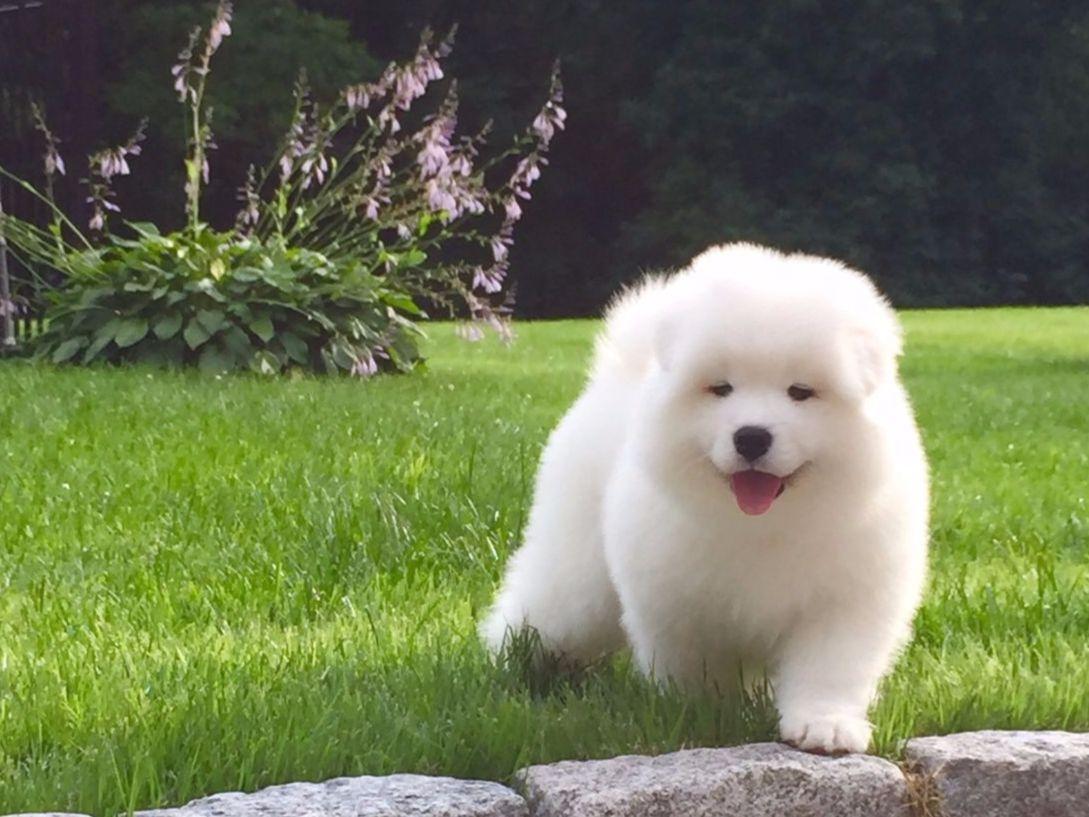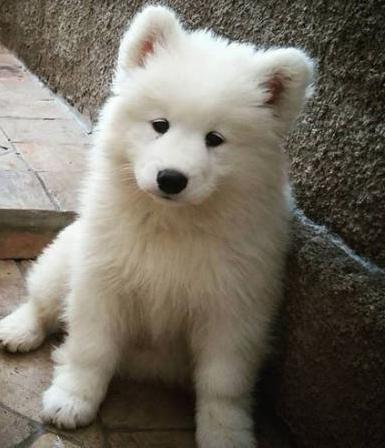The first image is the image on the left, the second image is the image on the right. For the images displayed, is the sentence "One image shows a small white pup next to a big white dog on green grass, and the other image contains exactly one white pup on a white surface." factually correct? Answer yes or no. No. The first image is the image on the left, the second image is the image on the right. Assess this claim about the two images: "One of the images shows an adult dog with a puppy on the grass.". Correct or not? Answer yes or no. No. 